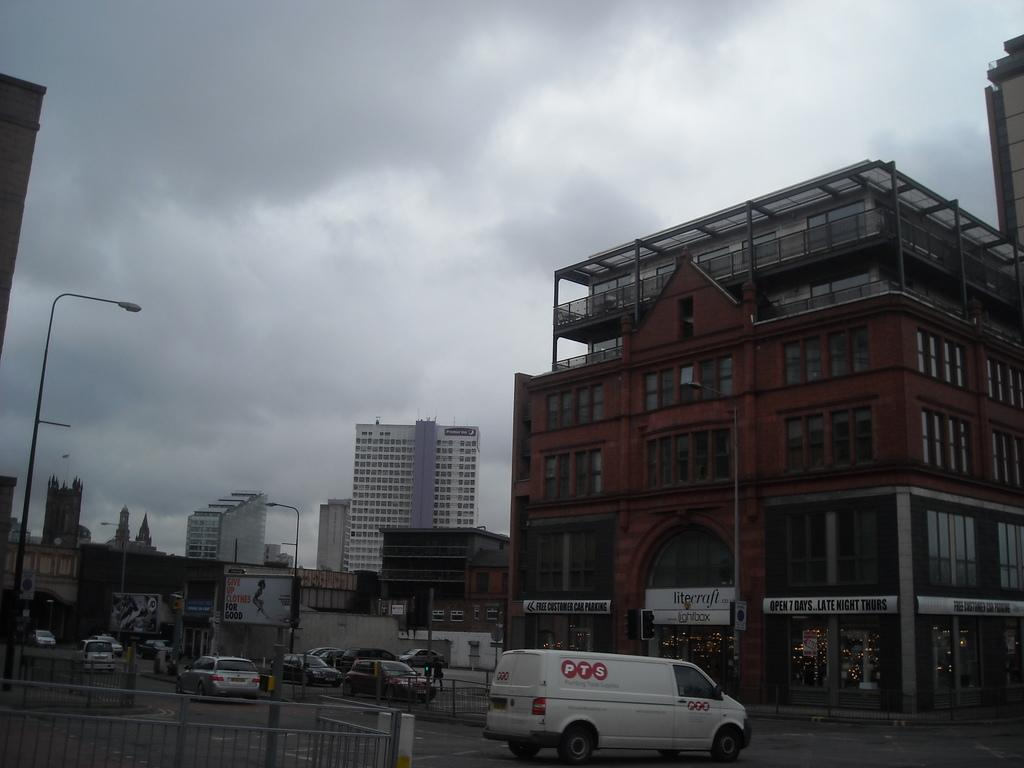What type of structures can be seen in the image? There are buildings in the image. What feature is visible on the buildings? There are windows visible in the image. What type of barrier is present in the image? There is fencing in the image. What type of street infrastructure is visible in the image? Light poles and traffic signals are visible in the image. What type of signage is present in the image? Boards are present in the image. What is visible in the sky in the image? The sky is visible in the image. What type of transportation is present on the road in the image? There are vehicles on the road in the image. Can you see a cup of coffee being held by a jellyfish in the image? No, there is no cup of coffee or jellyfish present in the image. Is the moon visible in the image? No, the moon is not visible in the image; only the sky is visible. 